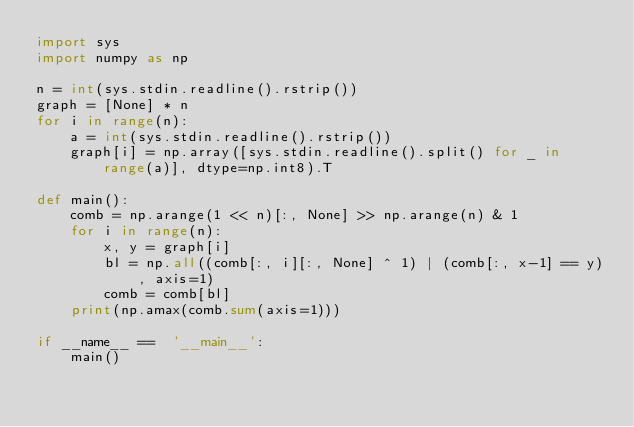Convert code to text. <code><loc_0><loc_0><loc_500><loc_500><_Python_>import sys
import numpy as np 

n = int(sys.stdin.readline().rstrip())
graph = [None] * n
for i in range(n):
    a = int(sys.stdin.readline().rstrip())
    graph[i] = np.array([sys.stdin.readline().split() for _ in range(a)], dtype=np.int8).T

def main():
    comb = np.arange(1 << n)[:, None] >> np.arange(n) & 1
    for i in range(n):
        x, y = graph[i]
        bl = np.all((comb[:, i][:, None] ^ 1) | (comb[:, x-1] == y), axis=1)
        comb = comb[bl]
    print(np.amax(comb.sum(axis=1)))

if __name__ ==  '__main__':
    main()
</code> 